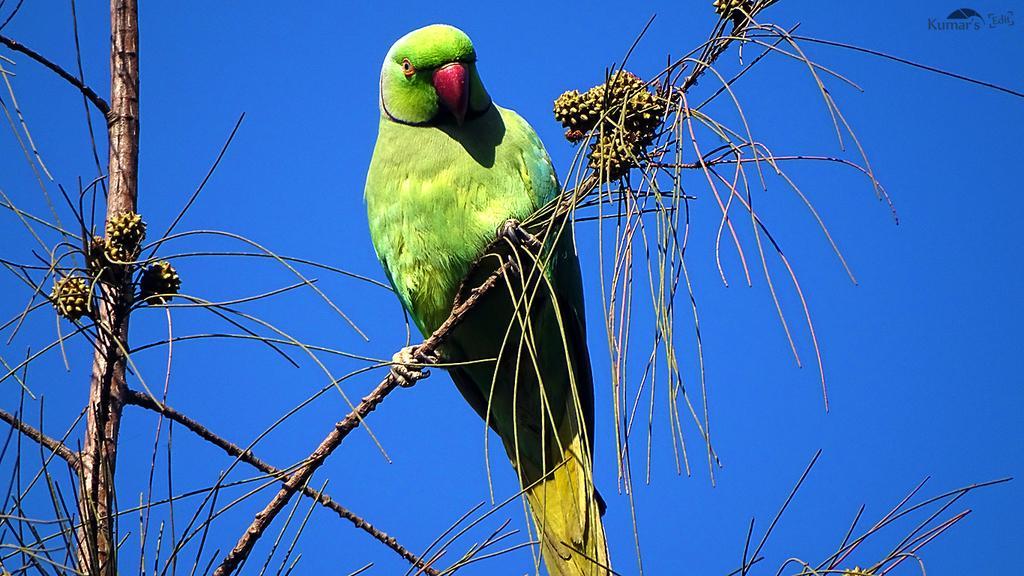In one or two sentences, can you explain what this image depicts? In this image we can see a parrot on the tree, there are some buds and in the background we can see the sky. 